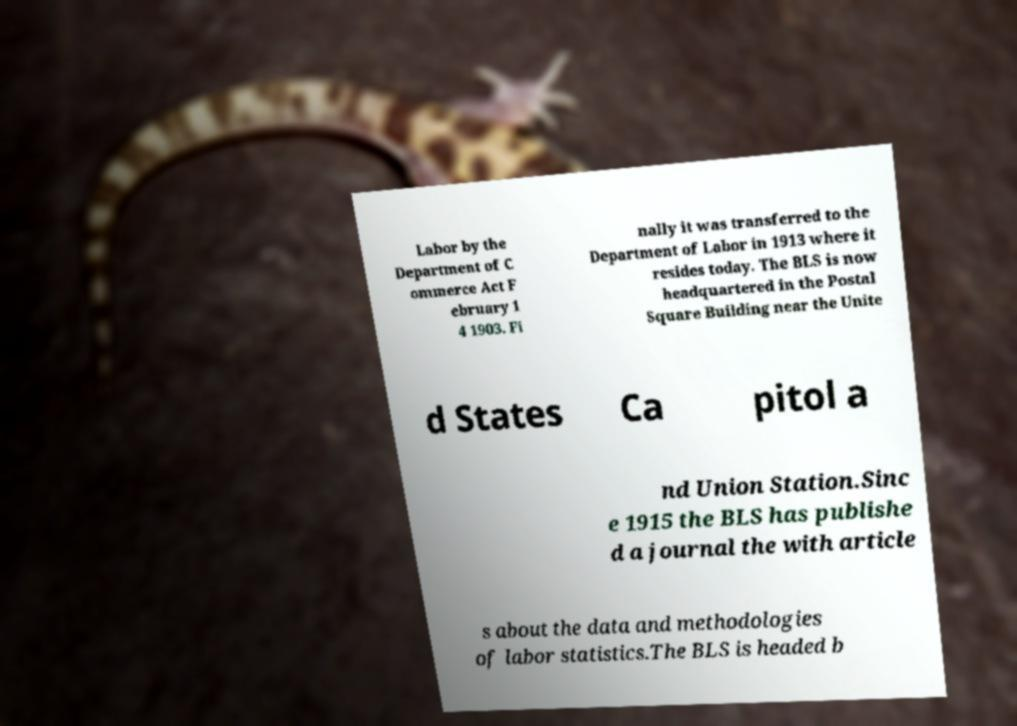Please read and relay the text visible in this image. What does it say? Labor by the Department of C ommerce Act F ebruary 1 4 1903. Fi nally it was transferred to the Department of Labor in 1913 where it resides today. The BLS is now headquartered in the Postal Square Building near the Unite d States Ca pitol a nd Union Station.Sinc e 1915 the BLS has publishe d a journal the with article s about the data and methodologies of labor statistics.The BLS is headed b 